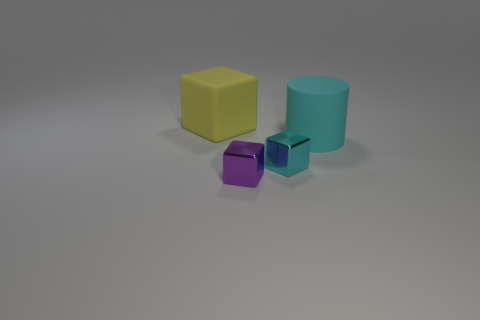There is a small thing that is the same color as the large cylinder; what is its material?
Your response must be concise. Metal. There is a matte object in front of the yellow rubber cube; what color is it?
Offer a very short reply. Cyan. Are there fewer cyan shiny cubes that are behind the big yellow matte object than big blue matte cubes?
Your answer should be very brief. No. Are the large cylinder and the tiny cyan block made of the same material?
Your response must be concise. No. There is a cyan object that is the same shape as the yellow rubber thing; what size is it?
Give a very brief answer. Small. What number of objects are either tiny metallic blocks that are to the right of the purple block or large things behind the big cyan object?
Keep it short and to the point. 2. Are there fewer gray metal cubes than cyan metal objects?
Give a very brief answer. Yes. There is a cyan cylinder; does it have the same size as the matte thing left of the cyan matte cylinder?
Ensure brevity in your answer.  Yes. How many shiny things are cylinders or green balls?
Give a very brief answer. 0. Is the number of big cyan rubber cylinders greater than the number of big cyan rubber cubes?
Ensure brevity in your answer.  Yes. 